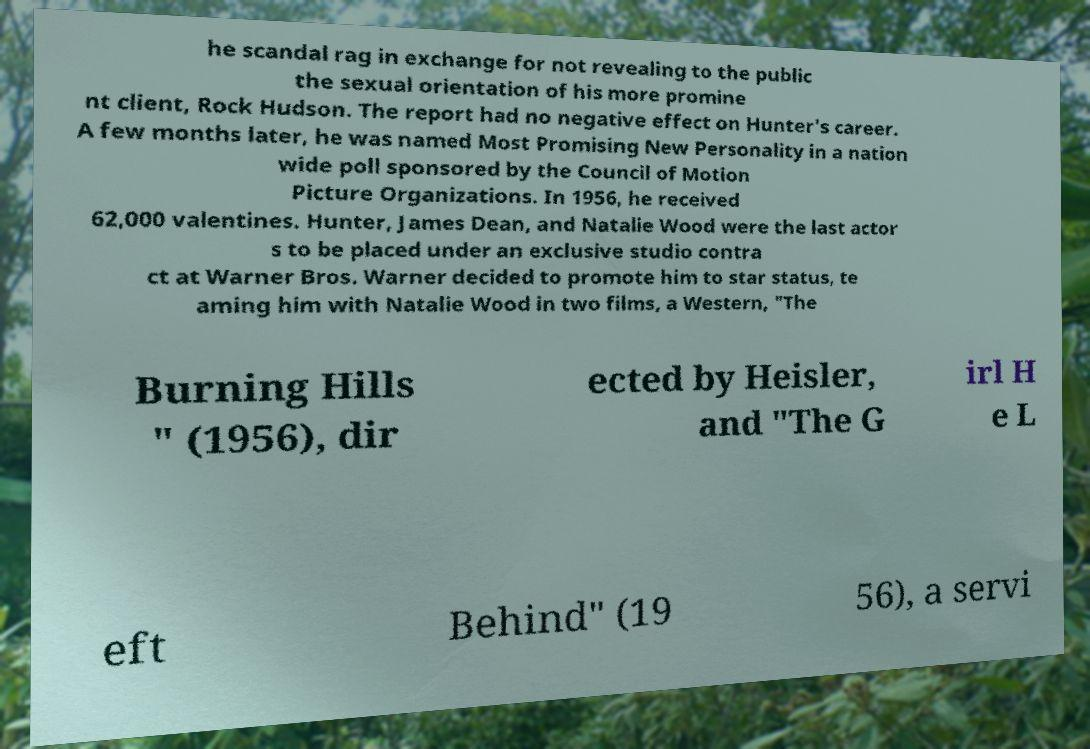I need the written content from this picture converted into text. Can you do that? he scandal rag in exchange for not revealing to the public the sexual orientation of his more promine nt client, Rock Hudson. The report had no negative effect on Hunter's career. A few months later, he was named Most Promising New Personality in a nation wide poll sponsored by the Council of Motion Picture Organizations. In 1956, he received 62,000 valentines. Hunter, James Dean, and Natalie Wood were the last actor s to be placed under an exclusive studio contra ct at Warner Bros. Warner decided to promote him to star status, te aming him with Natalie Wood in two films, a Western, "The Burning Hills " (1956), dir ected by Heisler, and "The G irl H e L eft Behind" (19 56), a servi 